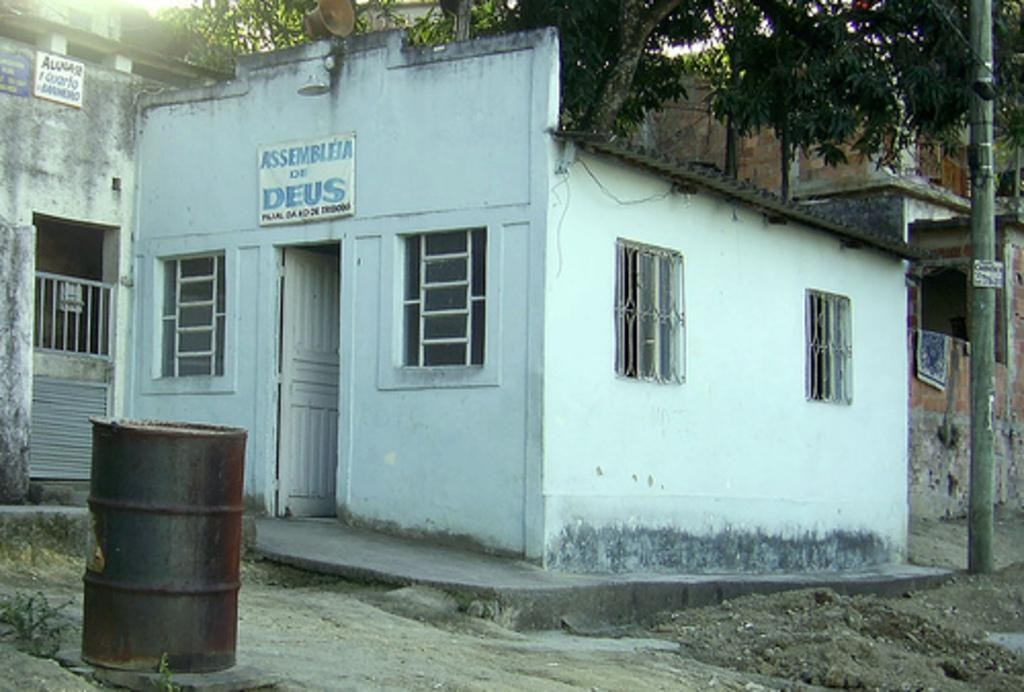<image>
Share a concise interpretation of the image provided. The sign for the Assembleia de Deus has faded blue letters. 